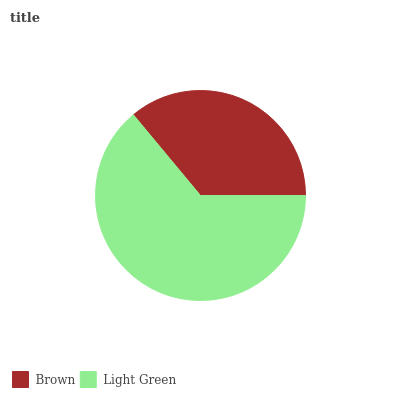Is Brown the minimum?
Answer yes or no. Yes. Is Light Green the maximum?
Answer yes or no. Yes. Is Light Green the minimum?
Answer yes or no. No. Is Light Green greater than Brown?
Answer yes or no. Yes. Is Brown less than Light Green?
Answer yes or no. Yes. Is Brown greater than Light Green?
Answer yes or no. No. Is Light Green less than Brown?
Answer yes or no. No. Is Light Green the high median?
Answer yes or no. Yes. Is Brown the low median?
Answer yes or no. Yes. Is Brown the high median?
Answer yes or no. No. Is Light Green the low median?
Answer yes or no. No. 